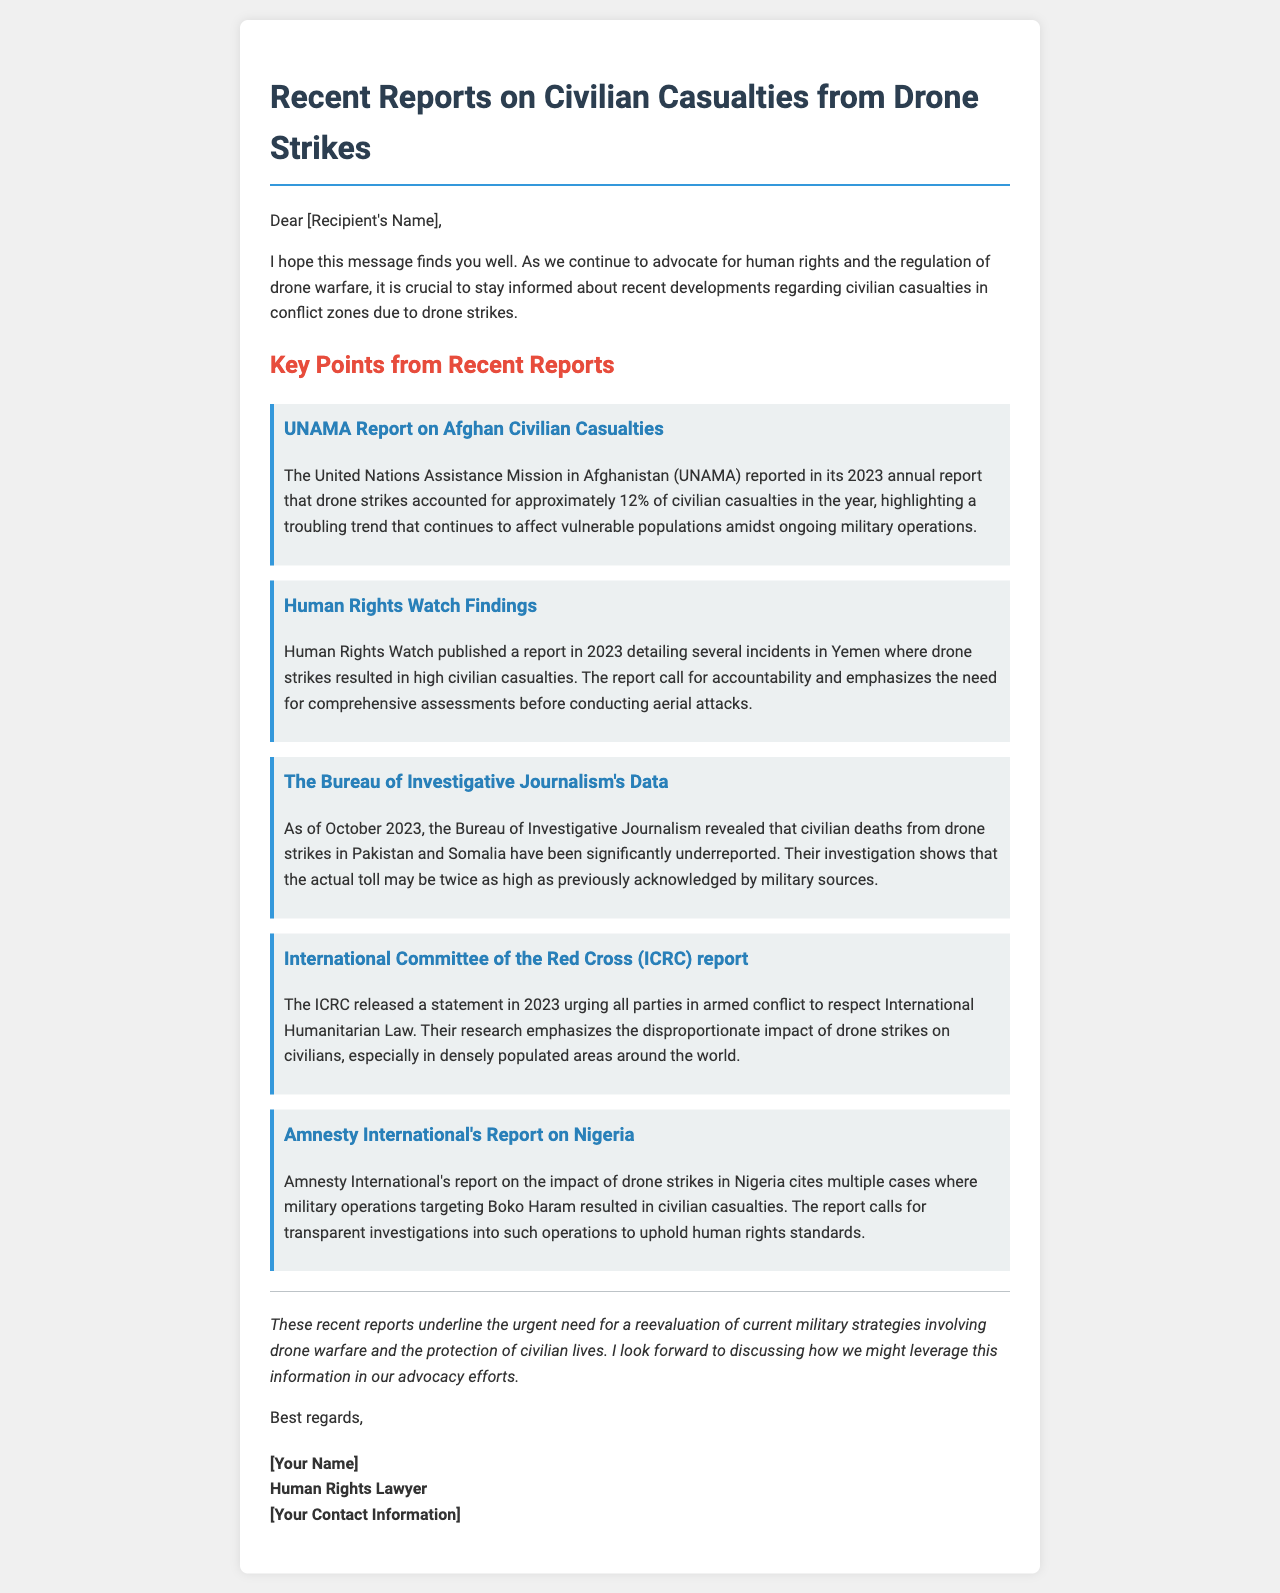What percentage of civilian casualties in Afghanistan were from drone strikes? The UNAMA report states that drone strikes accounted for approximately 12% of civilian casualties in Afghanistan in 2023.
Answer: 12% What organization published a report on drone strikes in Yemen? Human Rights Watch published a report detailing incidents of drone strikes in Yemen.
Answer: Human Rights Watch Which organization revealed underreported civilian deaths from drone strikes in Pakistan and Somalia? The Bureau of Investigative Journalism revealed that civilian deaths from drone strikes in these regions have been significantly underreported.
Answer: The Bureau of Investigative Journalism What does the ICRC urge all parties in armed conflict to respect? The ICRC released a statement urging all parties to respect International Humanitarian Law.
Answer: International Humanitarian Law What did Amnesty International's report on Nigeria call for? The report calls for transparent investigations into military operations targeting Boko Haram that resulted in civilian casualties.
Answer: Transparent investigations What year did the UNAMA report on Afghan civilian casualties get published? The UNAMA report was published in 2023.
Answer: 2023 What is the main focus of the discussed reports? The reports focus on civilian casualties resulting from drone strikes in various conflict zones.
Answer: Civilian casualties What is the concluding message of the email? The conclusion emphasizes the urgent need for a reevaluation of current military strategies involving drone warfare.
Answer: Reevaluation of military strategies 